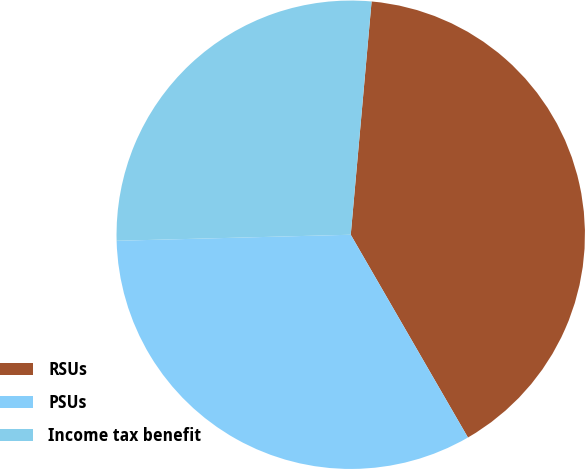Convert chart. <chart><loc_0><loc_0><loc_500><loc_500><pie_chart><fcel>RSUs<fcel>PSUs<fcel>Income tax benefit<nl><fcel>40.24%<fcel>32.93%<fcel>26.83%<nl></chart> 